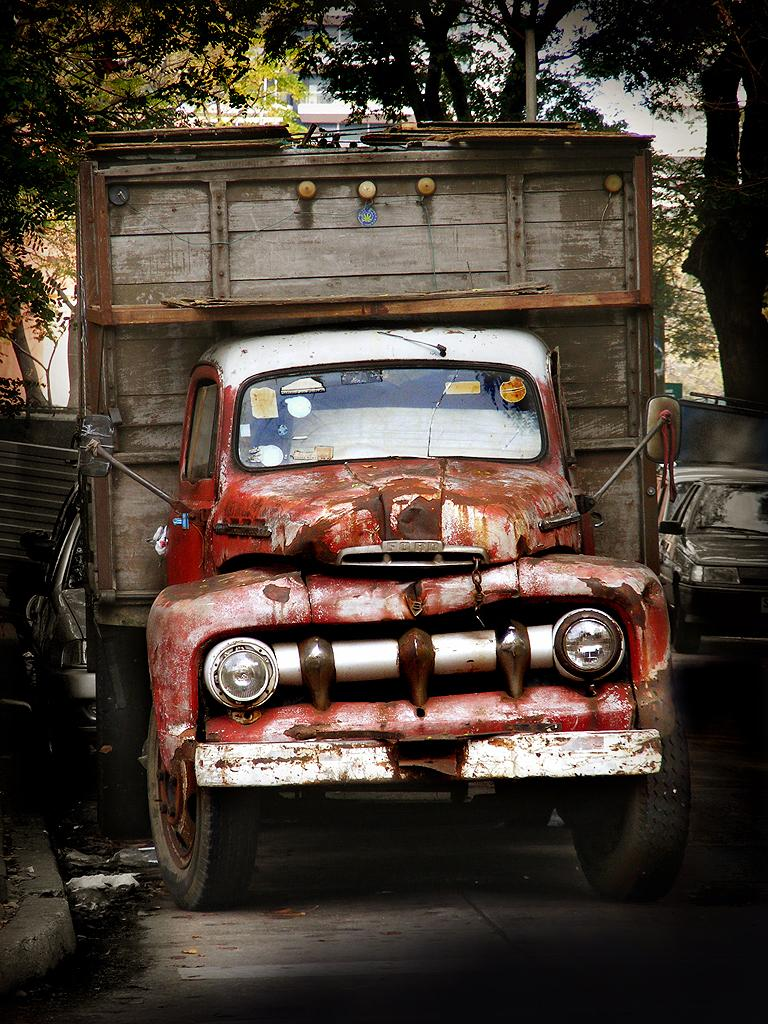What is the main subject of the image? The main subject of the image is a truck. What can be seen in the background of the image? There are trees visible in the image. How are the cars positioned in relation to the truck? The cars are parked behind and next to the truck. What is the weather like in the image? The sky is cloudy in the image. What type of love story is being told in the image? There is no love story present in the image; it features a truck, trees, and parked cars. What operation is being performed on the truck in the image? There is no operation being performed on the truck in the image; it is parked among other cars. 